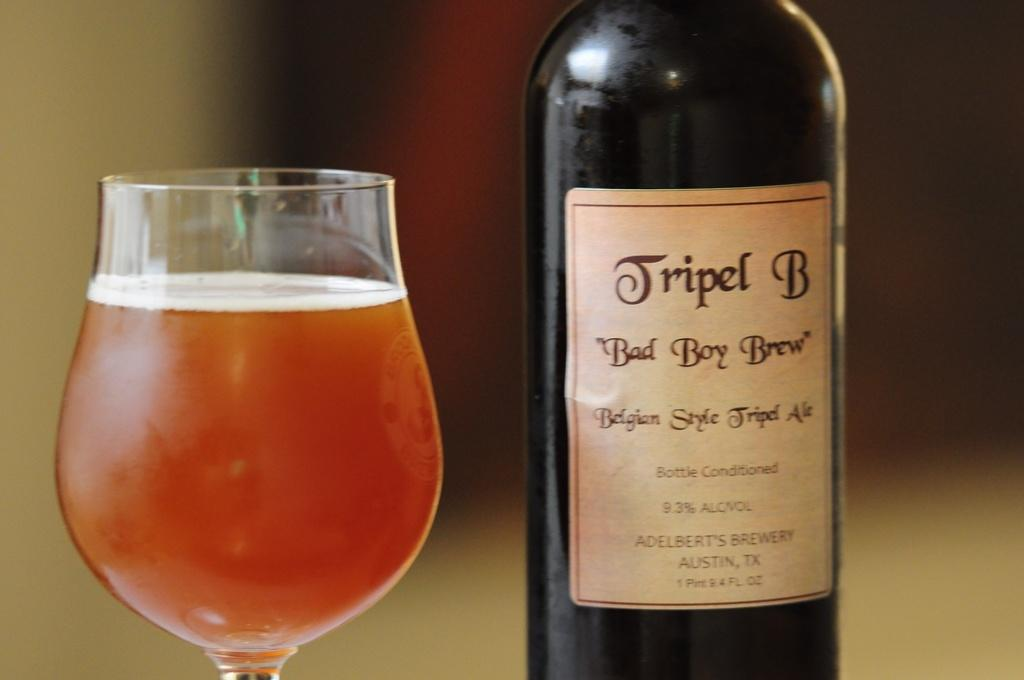<image>
Provide a brief description of the given image. A bottle of Tripel B Bad Boy Brew next to a full glass. 